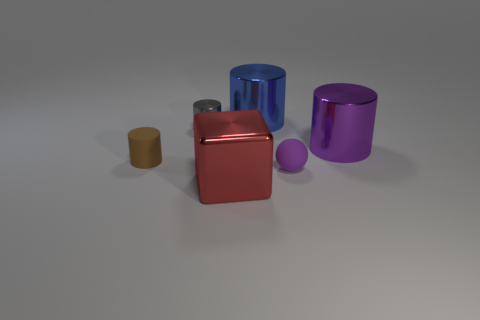What is the shape of the small thing to the right of the small cylinder that is behind the tiny rubber object behind the tiny purple matte sphere?
Provide a succinct answer. Sphere. Do the large red object and the brown rubber thing have the same shape?
Your answer should be compact. No. What number of other things are there of the same shape as the blue object?
Provide a short and direct response. 3. There is a metal cylinder that is the same size as the blue object; what color is it?
Give a very brief answer. Purple. Are there an equal number of red metal blocks that are on the right side of the tiny gray cylinder and large blue shiny objects?
Provide a short and direct response. Yes. There is a tiny thing that is in front of the small shiny thing and left of the purple matte thing; what shape is it?
Ensure brevity in your answer.  Cylinder. Is the size of the metal cube the same as the blue thing?
Your answer should be very brief. Yes. Are there any small brown objects made of the same material as the purple sphere?
Offer a very short reply. Yes. There is a cylinder that is the same color as the tiny ball; what is its size?
Provide a short and direct response. Large. What number of cylinders are to the left of the big blue cylinder and behind the tiny matte cylinder?
Make the answer very short. 1. 